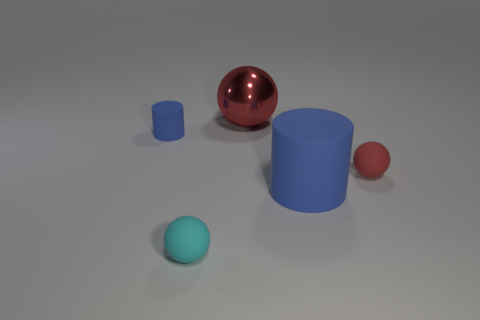How many other matte objects have the same color as the large rubber object?
Your answer should be compact. 1. Are there fewer matte spheres left of the small cyan sphere than large things?
Your response must be concise. Yes. Is there any other thing that is the same shape as the cyan matte object?
Give a very brief answer. Yes. There is a blue object right of the tiny blue cylinder; what is its shape?
Offer a terse response. Cylinder. The small red matte thing to the right of the red sphere that is behind the small matte object that is to the right of the cyan matte object is what shape?
Ensure brevity in your answer.  Sphere. What number of objects are tiny cyan balls or small matte cylinders?
Your answer should be very brief. 2. There is a shiny object that is on the left side of the large blue object; is its shape the same as the tiny thing that is left of the tiny cyan matte object?
Give a very brief answer. No. How many small things are on the left side of the big red thing and in front of the tiny cylinder?
Give a very brief answer. 1. What number of other things are the same size as the cyan rubber object?
Your answer should be compact. 2. What material is the small object that is left of the red matte sphere and on the right side of the small blue cylinder?
Give a very brief answer. Rubber. 